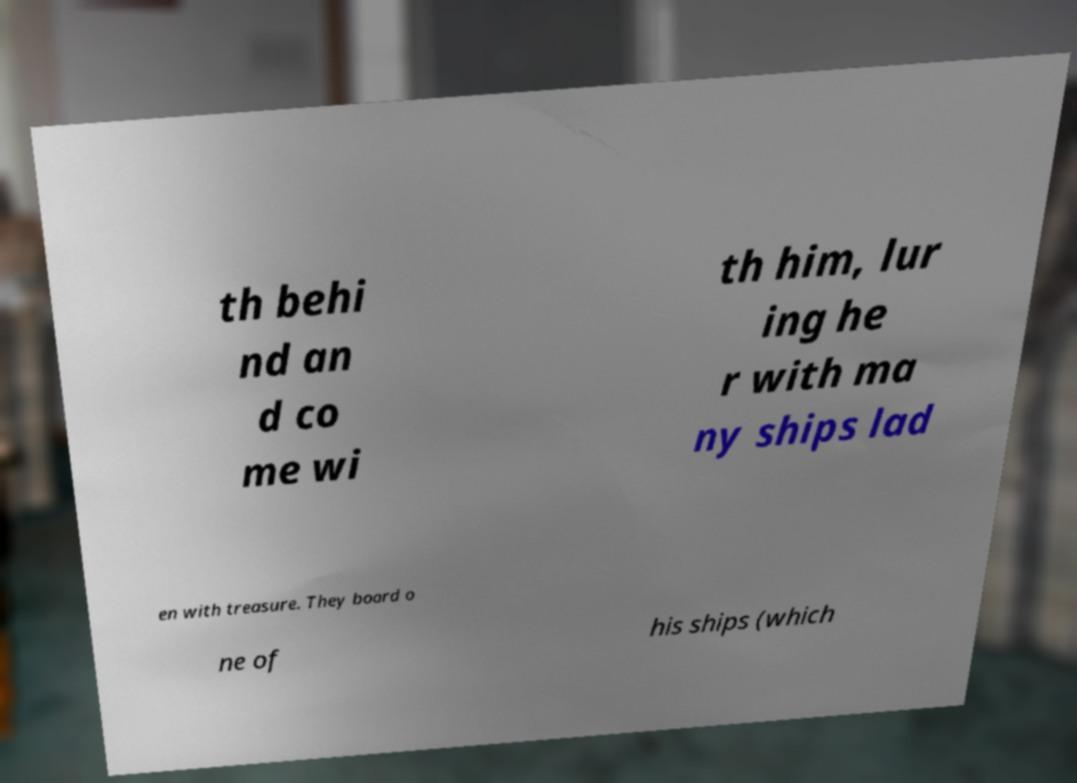What messages or text are displayed in this image? I need them in a readable, typed format. th behi nd an d co me wi th him, lur ing he r with ma ny ships lad en with treasure. They board o ne of his ships (which 